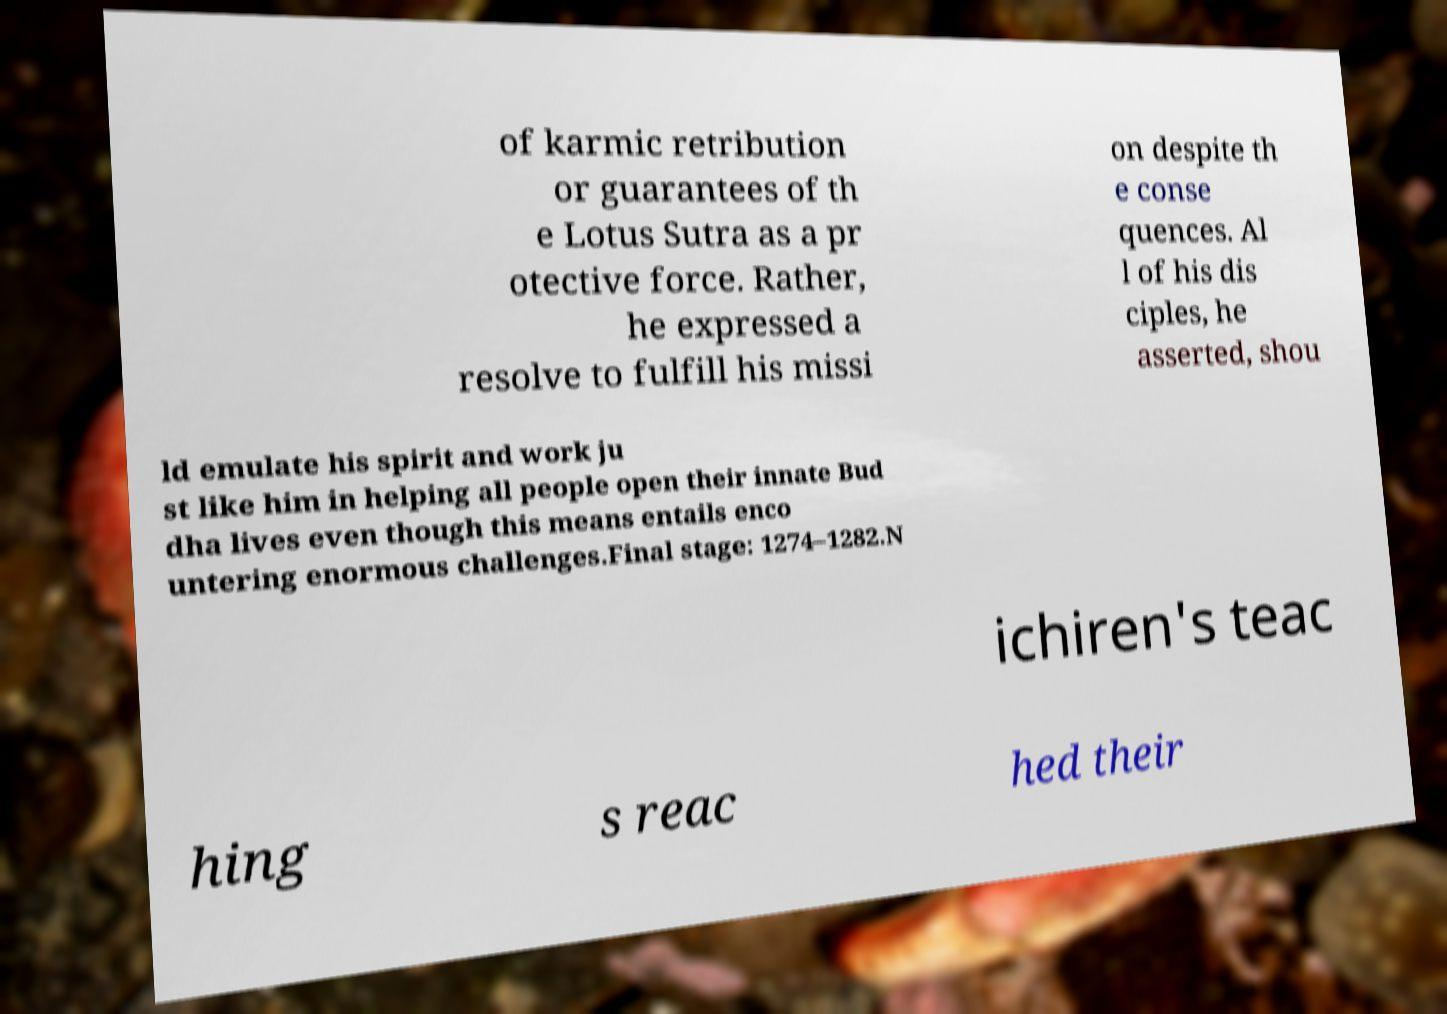Could you assist in decoding the text presented in this image and type it out clearly? of karmic retribution or guarantees of th e Lotus Sutra as a pr otective force. Rather, he expressed a resolve to fulfill his missi on despite th e conse quences. Al l of his dis ciples, he asserted, shou ld emulate his spirit and work ju st like him in helping all people open their innate Bud dha lives even though this means entails enco untering enormous challenges.Final stage: 1274–1282.N ichiren's teac hing s reac hed their 